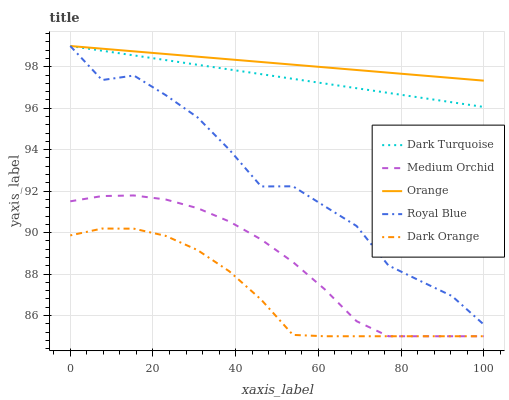Does Dark Orange have the minimum area under the curve?
Answer yes or no. Yes. Does Orange have the maximum area under the curve?
Answer yes or no. Yes. Does Dark Turquoise have the minimum area under the curve?
Answer yes or no. No. Does Dark Turquoise have the maximum area under the curve?
Answer yes or no. No. Is Orange the smoothest?
Answer yes or no. Yes. Is Royal Blue the roughest?
Answer yes or no. Yes. Is Dark Turquoise the smoothest?
Answer yes or no. No. Is Dark Turquoise the roughest?
Answer yes or no. No. Does Medium Orchid have the lowest value?
Answer yes or no. Yes. Does Dark Turquoise have the lowest value?
Answer yes or no. No. Does Royal Blue have the highest value?
Answer yes or no. Yes. Does Medium Orchid have the highest value?
Answer yes or no. No. Is Medium Orchid less than Royal Blue?
Answer yes or no. Yes. Is Royal Blue greater than Dark Orange?
Answer yes or no. Yes. Does Orange intersect Royal Blue?
Answer yes or no. Yes. Is Orange less than Royal Blue?
Answer yes or no. No. Is Orange greater than Royal Blue?
Answer yes or no. No. Does Medium Orchid intersect Royal Blue?
Answer yes or no. No. 